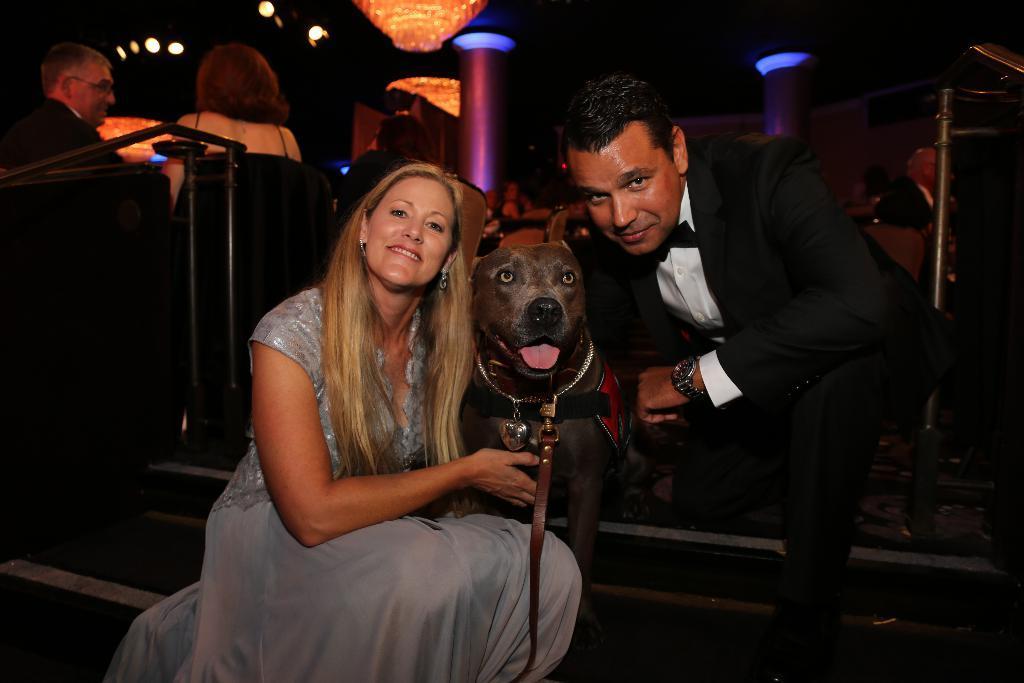Can you describe this image briefly? A lady wearing a gown is smiling. A man wearing a coat and a watch. And a dog is between them wearing a belt. In the background there are some other persons. Lights are there. Pillars are there. 